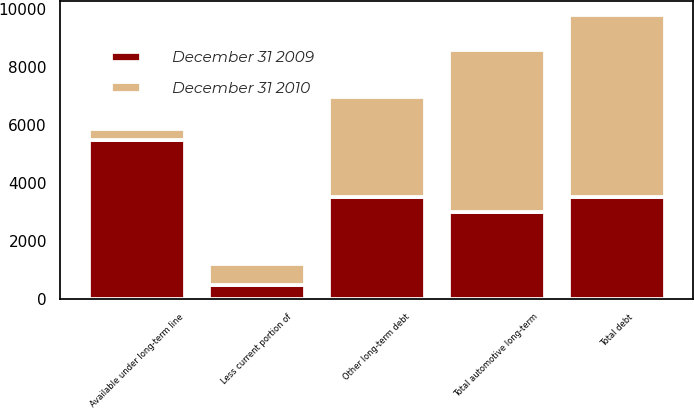<chart> <loc_0><loc_0><loc_500><loc_500><stacked_bar_chart><ecel><fcel>Other long-term debt<fcel>Total debt<fcel>Less current portion of<fcel>Total automotive long-term<fcel>Available under long-term line<nl><fcel>December 31 2009<fcel>3507<fcel>3507<fcel>493<fcel>3014<fcel>5474<nl><fcel>December 31 2010<fcel>3461<fcel>6286<fcel>724<fcel>5562<fcel>398<nl></chart> 